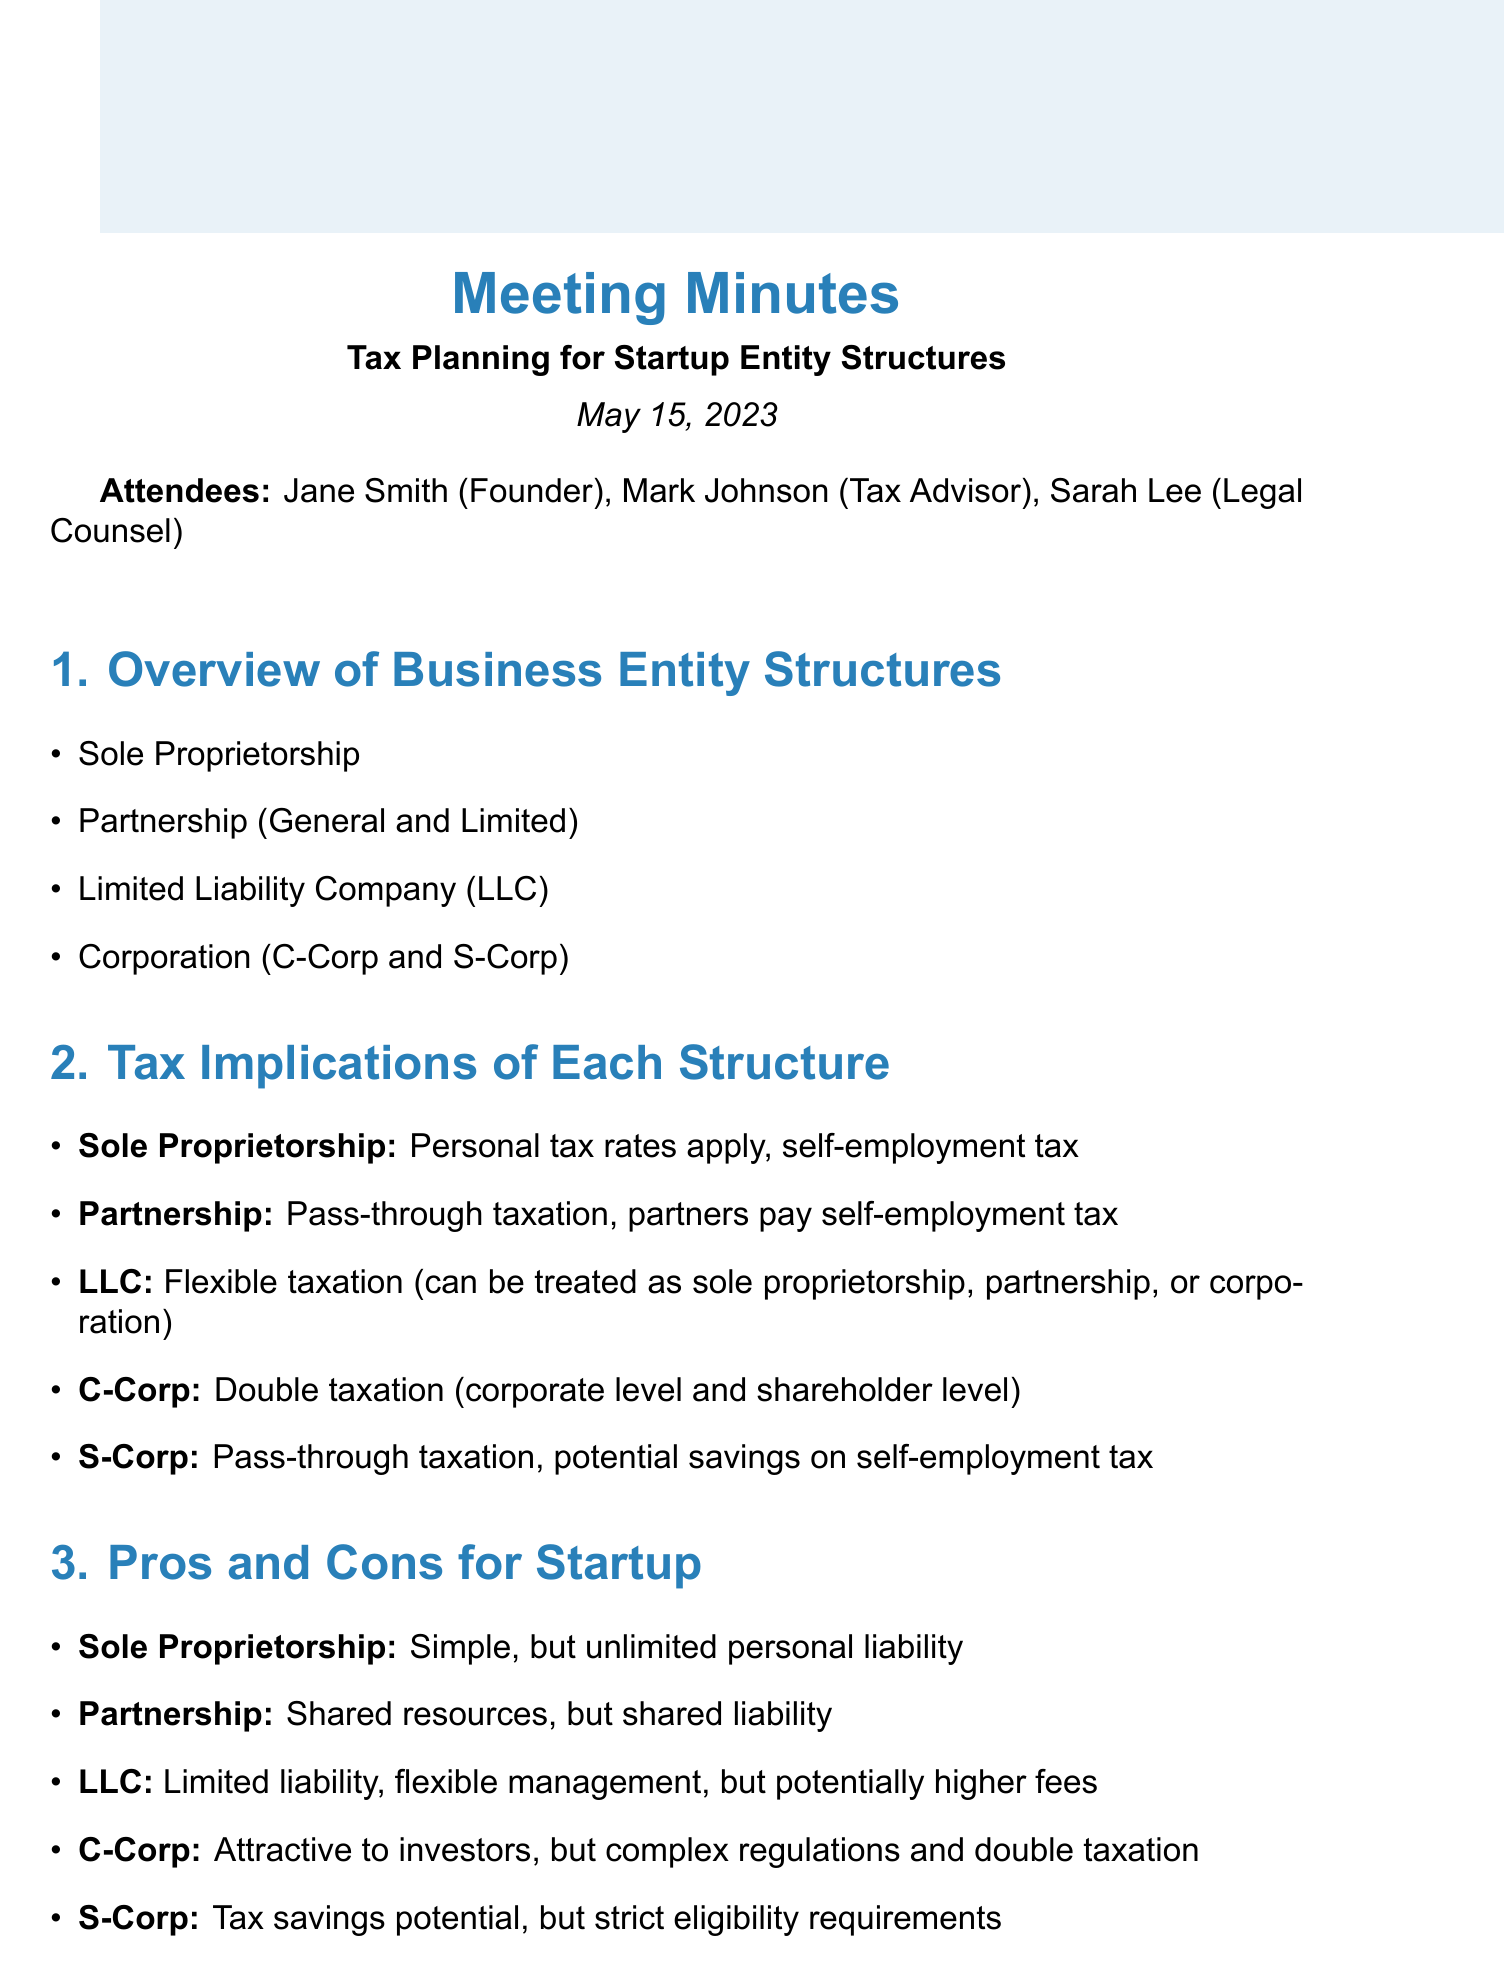What is the date of the meeting? The date of the meeting is specified in the document as May 15, 2023.
Answer: May 15, 2023 Who is the tax advisor present in the meeting? The tax advisor mentioned in the attendees section is Mark Johnson.
Answer: Mark Johnson What type of entity structure applies personal tax rates? The tax implications section mentions that a Sole Proprietorship applies personal tax rates.
Answer: Sole Proprietorship What is one disadvantage of a Corporation? The pros and cons section outlines that a Corporation has complex regulations and double taxation as a disadvantage.
Answer: Double taxation What is a benefit of choosing an S-Corp? According to the pros and cons section, an S-Corp offers tax savings potential as a benefit.
Answer: Tax savings potential What should be researched for next steps? The next steps in the document state that state-specific requirements and fees should be researched.
Answer: State-specific requirements and fees What is one consideration for future growth? The considerations section lists scalability of the chosen structure as one of the important factors for future growth.
Answer: Scalability of chosen structure How many attendees were present at the meeting? The attendees section lists three individuals present at the meeting.
Answer: Three What is the main title of the agenda item discussing tax implications? The agenda item title that discusses tax implications is "Tax Implications of Each Structure."
Answer: Tax Implications of Each Structure 